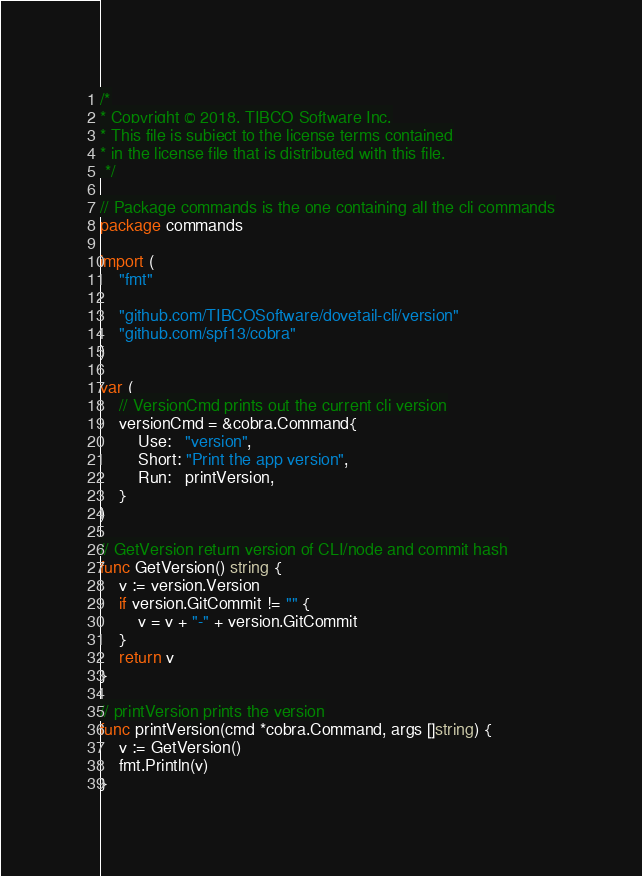<code> <loc_0><loc_0><loc_500><loc_500><_Go_>/*
* Copyright © 2018. TIBCO Software Inc.
* This file is subject to the license terms contained
* in the license file that is distributed with this file.
 */

// Package commands is the one containing all the cli commands
package commands

import (
	"fmt"

	"github.com/TIBCOSoftware/dovetail-cli/version"
	"github.com/spf13/cobra"
)

var (
	// VersionCmd prints out the current cli version
	versionCmd = &cobra.Command{
		Use:   "version",
		Short: "Print the app version",
		Run:   printVersion,
	}
)

// GetVersion return version of CLI/node and commit hash
func GetVersion() string {
	v := version.Version
	if version.GitCommit != "" {
		v = v + "-" + version.GitCommit
	}
	return v
}

// printVersion prints the version
func printVersion(cmd *cobra.Command, args []string) {
	v := GetVersion()
	fmt.Println(v)
}
</code> 